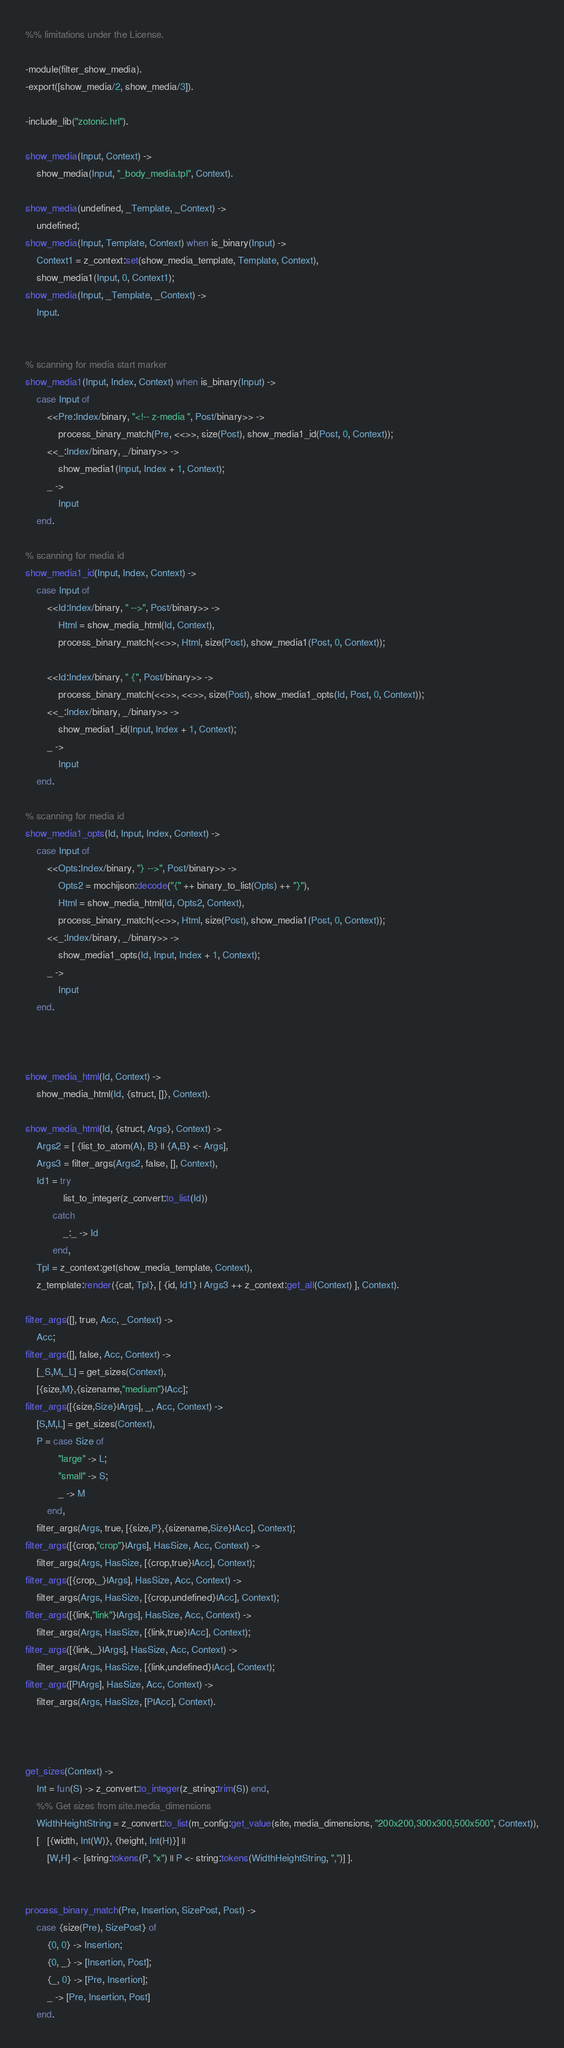<code> <loc_0><loc_0><loc_500><loc_500><_Erlang_>%% limitations under the License.

-module(filter_show_media).
-export([show_media/2, show_media/3]).

-include_lib("zotonic.hrl").

show_media(Input, Context) ->
    show_media(Input, "_body_media.tpl", Context).

show_media(undefined, _Template, _Context) ->
    undefined;
show_media(Input, Template, Context) when is_binary(Input) ->
    Context1 = z_context:set(show_media_template, Template, Context),
    show_media1(Input, 0, Context1);
show_media(Input, _Template, _Context) ->
    Input.


% scanning for media start marker
show_media1(Input, Index, Context) when is_binary(Input) ->
    case Input of
        <<Pre:Index/binary, "<!-- z-media ", Post/binary>> ->
            process_binary_match(Pre, <<>>, size(Post), show_media1_id(Post, 0, Context));
        <<_:Index/binary, _/binary>> ->
            show_media1(Input, Index + 1, Context);
        _ ->
            Input
    end.

% scanning for media id
show_media1_id(Input, Index, Context) ->
    case Input of
        <<Id:Index/binary, " -->", Post/binary>> ->
            Html = show_media_html(Id, Context),
            process_binary_match(<<>>, Html, size(Post), show_media1(Post, 0, Context));

        <<Id:Index/binary, " {", Post/binary>> ->
            process_binary_match(<<>>, <<>>, size(Post), show_media1_opts(Id, Post, 0, Context));
        <<_:Index/binary, _/binary>> ->
            show_media1_id(Input, Index + 1, Context);
        _ ->
            Input
    end.

% scanning for media id
show_media1_opts(Id, Input, Index, Context) ->
    case Input of
        <<Opts:Index/binary, "} -->", Post/binary>> ->
            Opts2 = mochijson:decode("{" ++ binary_to_list(Opts) ++ "}"),
            Html = show_media_html(Id, Opts2, Context),
            process_binary_match(<<>>, Html, size(Post), show_media1(Post, 0, Context));
        <<_:Index/binary, _/binary>> ->
            show_media1_opts(Id, Input, Index + 1, Context);
        _ ->
            Input
    end.



show_media_html(Id, Context) ->
    show_media_html(Id, {struct, []}, Context).

show_media_html(Id, {struct, Args}, Context) ->
    Args2 = [ {list_to_atom(A), B} || {A,B} <- Args],
    Args3 = filter_args(Args2, false, [], Context),
    Id1 = try 
              list_to_integer(z_convert:to_list(Id))
          catch
              _:_ -> Id
          end,
    Tpl = z_context:get(show_media_template, Context),
    z_template:render({cat, Tpl}, [ {id, Id1} | Args3 ++ z_context:get_all(Context) ], Context).

filter_args([], true, Acc, _Context) ->
    Acc;
filter_args([], false, Acc, Context) ->
    [_S,M,_L] = get_sizes(Context),
    [{size,M},{sizename,"medium"}|Acc];
filter_args([{size,Size}|Args], _, Acc, Context) ->
    [S,M,L] = get_sizes(Context),
    P = case Size of
            "large" -> L;
            "small" -> S;
            _ -> M
        end,
    filter_args(Args, true, [{size,P},{sizename,Size}|Acc], Context);
filter_args([{crop,"crop"}|Args], HasSize, Acc, Context) ->
    filter_args(Args, HasSize, [{crop,true}|Acc], Context);
filter_args([{crop,_}|Args], HasSize, Acc, Context) ->
    filter_args(Args, HasSize, [{crop,undefined}|Acc], Context);
filter_args([{link,"link"}|Args], HasSize, Acc, Context) ->
    filter_args(Args, HasSize, [{link,true}|Acc], Context);
filter_args([{link,_}|Args], HasSize, Acc, Context) ->
    filter_args(Args, HasSize, [{link,undefined}|Acc], Context);
filter_args([P|Args], HasSize, Acc, Context) ->
    filter_args(Args, HasSize, [P|Acc], Context).



get_sizes(Context) ->
    Int = fun(S) -> z_convert:to_integer(z_string:trim(S)) end,
    %% Get sizes from site.media_dimensions
    WidthHeightString = z_convert:to_list(m_config:get_value(site, media_dimensions, "200x200,300x300,500x500", Context)),
    [   [{width, Int(W)}, {height, Int(H)}] ||
        [W,H] <- [string:tokens(P, "x") || P <- string:tokens(WidthHeightString, ",")] ].


process_binary_match(Pre, Insertion, SizePost, Post) ->
    case {size(Pre), SizePost} of
        {0, 0} -> Insertion;
        {0, _} -> [Insertion, Post];
        {_, 0} -> [Pre, Insertion];
        _ -> [Pre, Insertion, Post]
    end.
</code> 